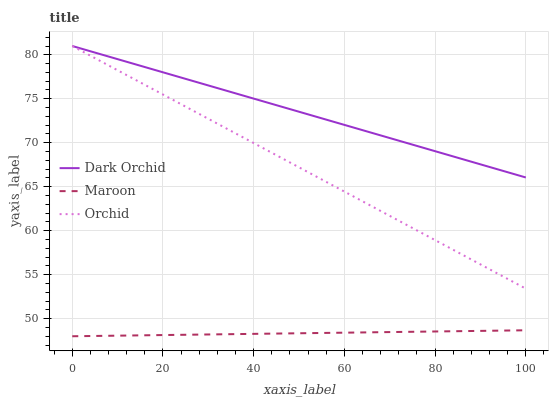Does Orchid have the minimum area under the curve?
Answer yes or no. No. Does Orchid have the maximum area under the curve?
Answer yes or no. No. Is Orchid the smoothest?
Answer yes or no. No. Is Orchid the roughest?
Answer yes or no. No. Does Orchid have the lowest value?
Answer yes or no. No. Is Maroon less than Dark Orchid?
Answer yes or no. Yes. Is Dark Orchid greater than Maroon?
Answer yes or no. Yes. Does Maroon intersect Dark Orchid?
Answer yes or no. No. 